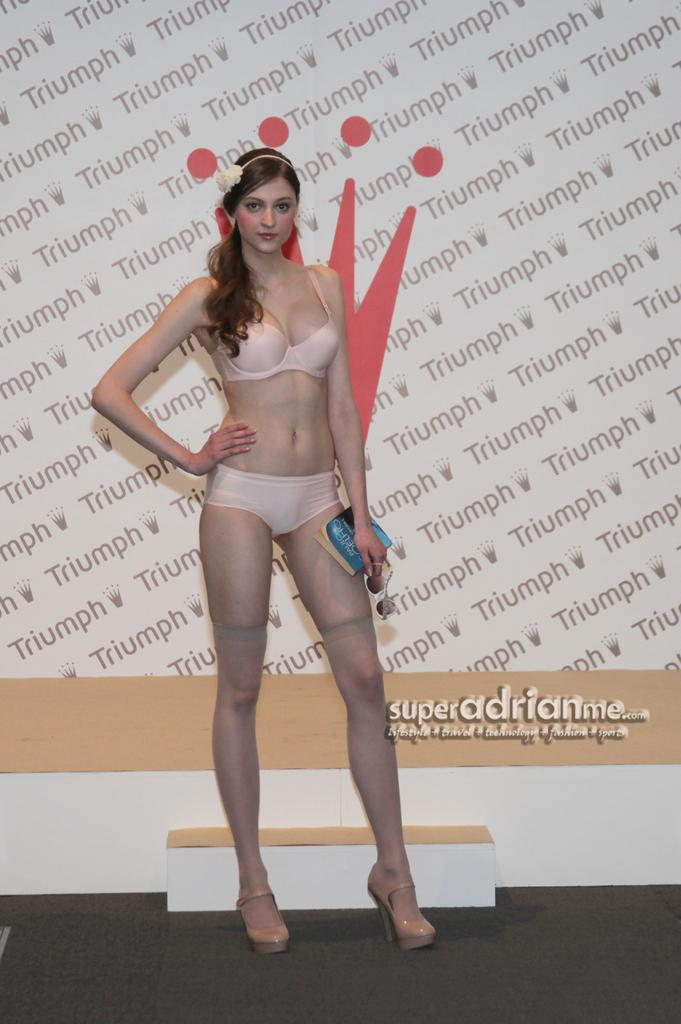Who is the main subject in the image? There is a woman standing in the center of the image. What is the woman standing on? The woman is standing on the floor. What can be seen in the background of the image? There is an advertisement in the background of the image. What type of chin can be seen on the band members in the image? There is no band present in the image, so there are no band members or their chins to observe. 